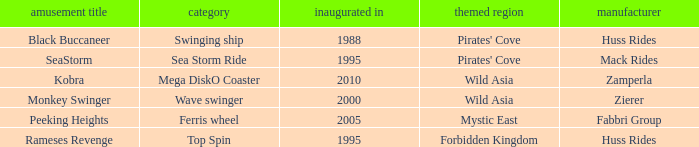What amusement ride was created by zierer? Monkey Swinger. 